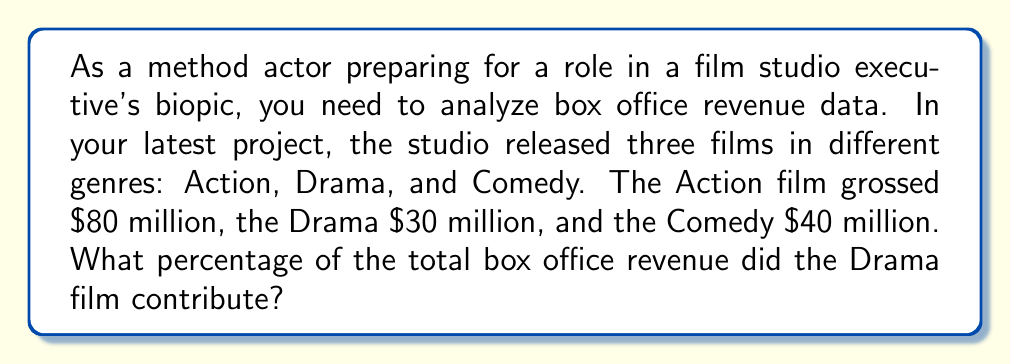Help me with this question. Let's approach this step-by-step:

1. Calculate the total box office revenue:
   $$\text{Total Revenue} = \$80\text{ million} + \$30\text{ million} + \$40\text{ million} = \$150\text{ million}$$

2. Identify the revenue of the Drama film:
   $$\text{Drama Revenue} = \$30\text{ million}$$

3. Calculate the percentage using the formula:
   $$\text{Percentage} = \frac{\text{Drama Revenue}}{\text{Total Revenue}} \times 100\%$$

4. Plug in the values:
   $$\text{Percentage} = \frac{\$30\text{ million}}{\$150\text{ million}} \times 100\%$$

5. Simplify the fraction:
   $$\text{Percentage} = \frac{30}{150} \times 100\% = \frac{1}{5} \times 100\% = 20\%$$

Therefore, the Drama film contributed 20% of the total box office revenue.
Answer: 20% 